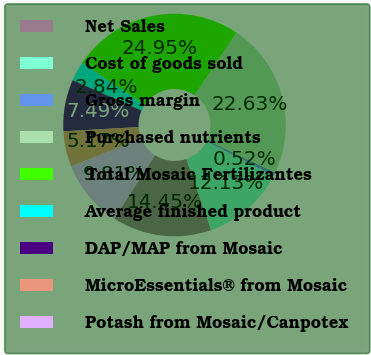Convert chart to OTSL. <chart><loc_0><loc_0><loc_500><loc_500><pie_chart><fcel>Net Sales<fcel>Cost of goods sold<fcel>Gross margin<fcel>Purchased nutrients<fcel>Total Mosaic Fertilizantes<fcel>Average finished product<fcel>DAP/MAP from Mosaic<fcel>MicroEssentials® from Mosaic<fcel>Potash from Mosaic/Canpotex<nl><fcel>14.45%<fcel>12.13%<fcel>0.52%<fcel>22.63%<fcel>24.95%<fcel>2.84%<fcel>7.49%<fcel>5.17%<fcel>9.81%<nl></chart> 